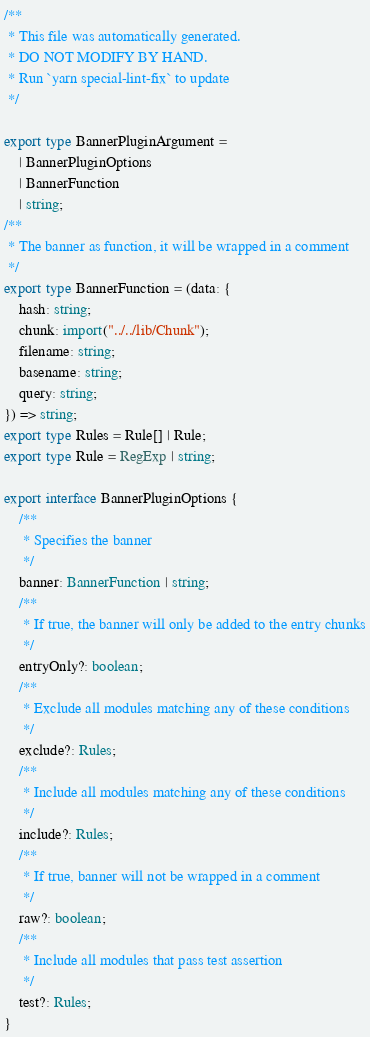Convert code to text. <code><loc_0><loc_0><loc_500><loc_500><_TypeScript_>/**
 * This file was automatically generated.
 * DO NOT MODIFY BY HAND.
 * Run `yarn special-lint-fix` to update
 */

export type BannerPluginArgument =
	| BannerPluginOptions
	| BannerFunction
	| string;
/**
 * The banner as function, it will be wrapped in a comment
 */
export type BannerFunction = (data: {
	hash: string;
	chunk: import("../../lib/Chunk");
	filename: string;
	basename: string;
	query: string;
}) => string;
export type Rules = Rule[] | Rule;
export type Rule = RegExp | string;

export interface BannerPluginOptions {
	/**
	 * Specifies the banner
	 */
	banner: BannerFunction | string;
	/**
	 * If true, the banner will only be added to the entry chunks
	 */
	entryOnly?: boolean;
	/**
	 * Exclude all modules matching any of these conditions
	 */
	exclude?: Rules;
	/**
	 * Include all modules matching any of these conditions
	 */
	include?: Rules;
	/**
	 * If true, banner will not be wrapped in a comment
	 */
	raw?: boolean;
	/**
	 * Include all modules that pass test assertion
	 */
	test?: Rules;
}
</code> 